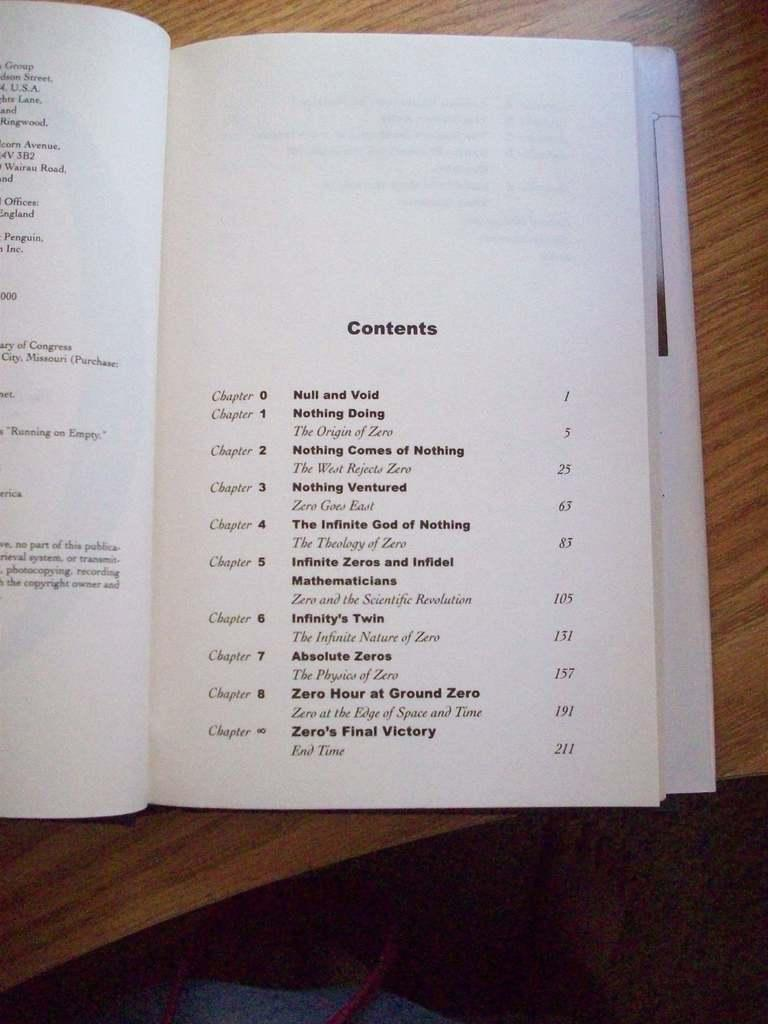<image>
Describe the image concisely. A book that is opened to the front contents page. 